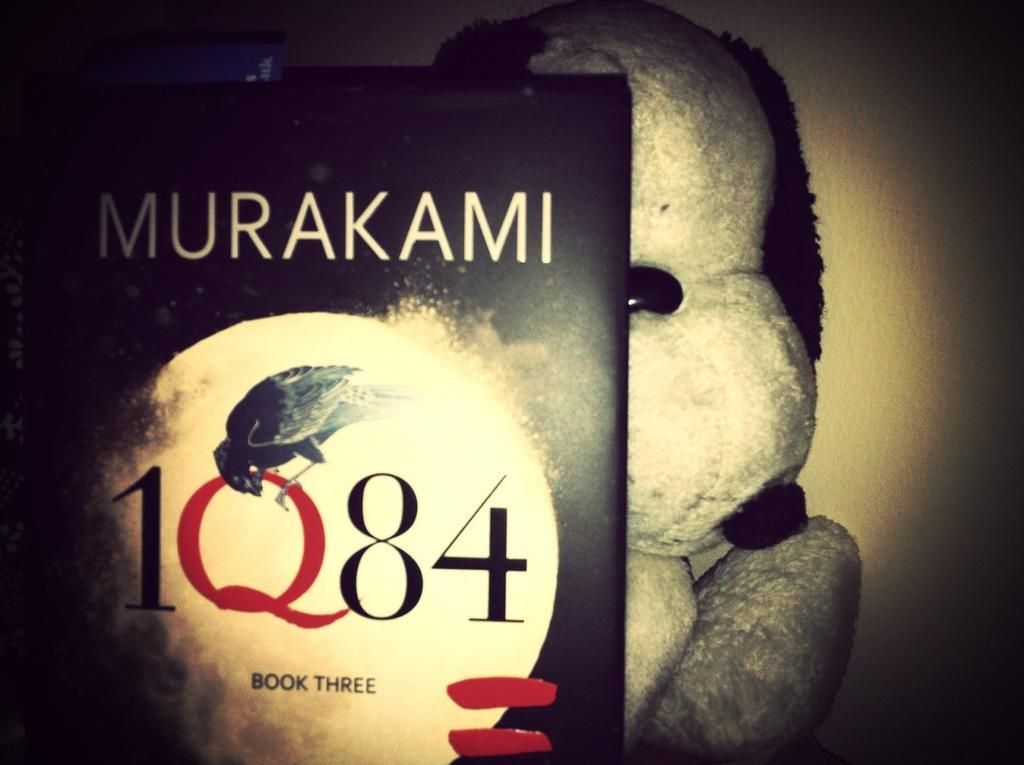<image>
Describe the image concisely. A stuffed animal appears to be holding up a book written by Murakami. 